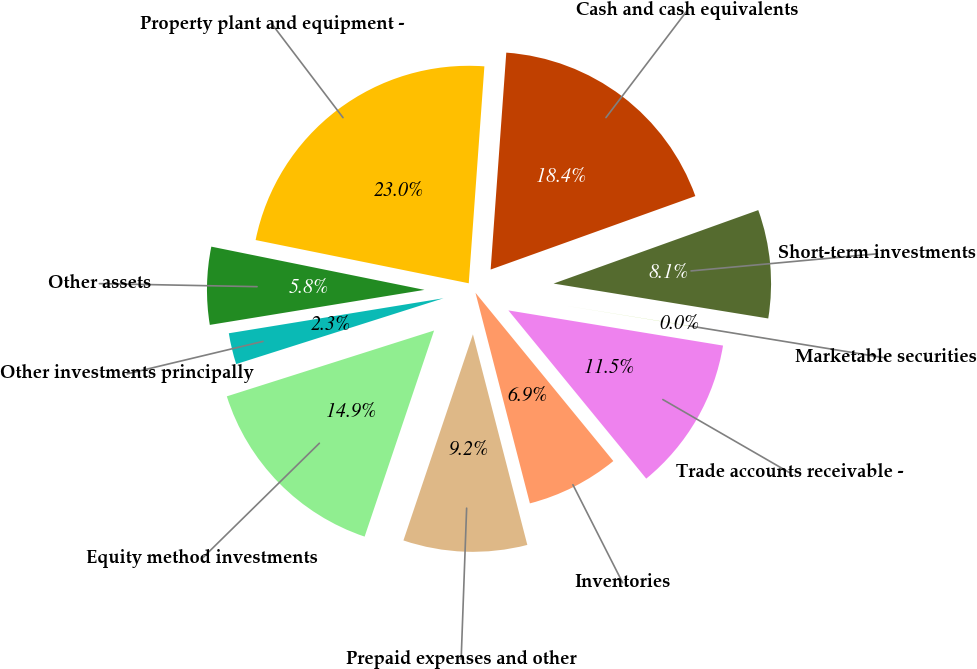Convert chart to OTSL. <chart><loc_0><loc_0><loc_500><loc_500><pie_chart><fcel>Cash and cash equivalents<fcel>Short-term investments<fcel>Marketable securities<fcel>Trade accounts receivable -<fcel>Inventories<fcel>Prepaid expenses and other<fcel>Equity method investments<fcel>Other investments principally<fcel>Other assets<fcel>Property plant and equipment -<nl><fcel>18.37%<fcel>8.05%<fcel>0.02%<fcel>11.49%<fcel>6.9%<fcel>9.2%<fcel>14.93%<fcel>2.32%<fcel>5.76%<fcel>22.96%<nl></chart> 